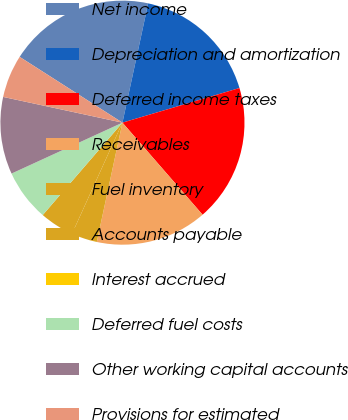Convert chart to OTSL. <chart><loc_0><loc_0><loc_500><loc_500><pie_chart><fcel>Net income<fcel>Depreciation and amortization<fcel>Deferred income taxes<fcel>Receivables<fcel>Fuel inventory<fcel>Accounts payable<fcel>Interest accrued<fcel>Deferred fuel costs<fcel>Other working capital accounts<fcel>Provisions for estimated<nl><fcel>19.32%<fcel>17.04%<fcel>18.18%<fcel>14.77%<fcel>3.41%<fcel>4.55%<fcel>0.0%<fcel>6.82%<fcel>10.23%<fcel>5.68%<nl></chart> 